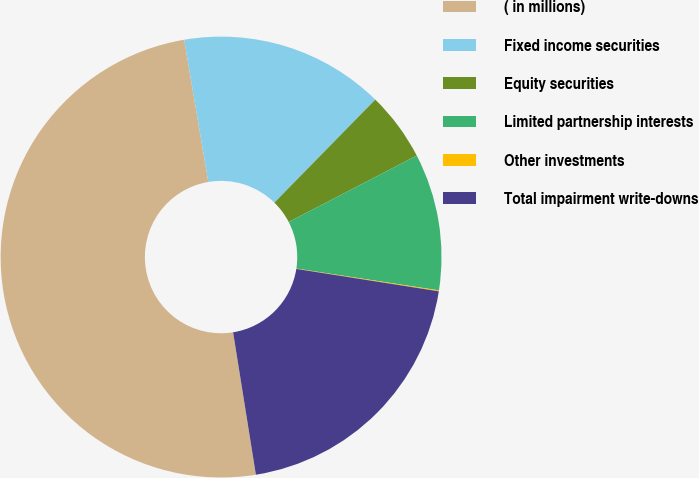<chart> <loc_0><loc_0><loc_500><loc_500><pie_chart><fcel>( in millions)<fcel>Fixed income securities<fcel>Equity securities<fcel>Limited partnership interests<fcel>Other investments<fcel>Total impairment write-downs<nl><fcel>49.85%<fcel>15.01%<fcel>5.05%<fcel>10.03%<fcel>0.07%<fcel>19.99%<nl></chart> 